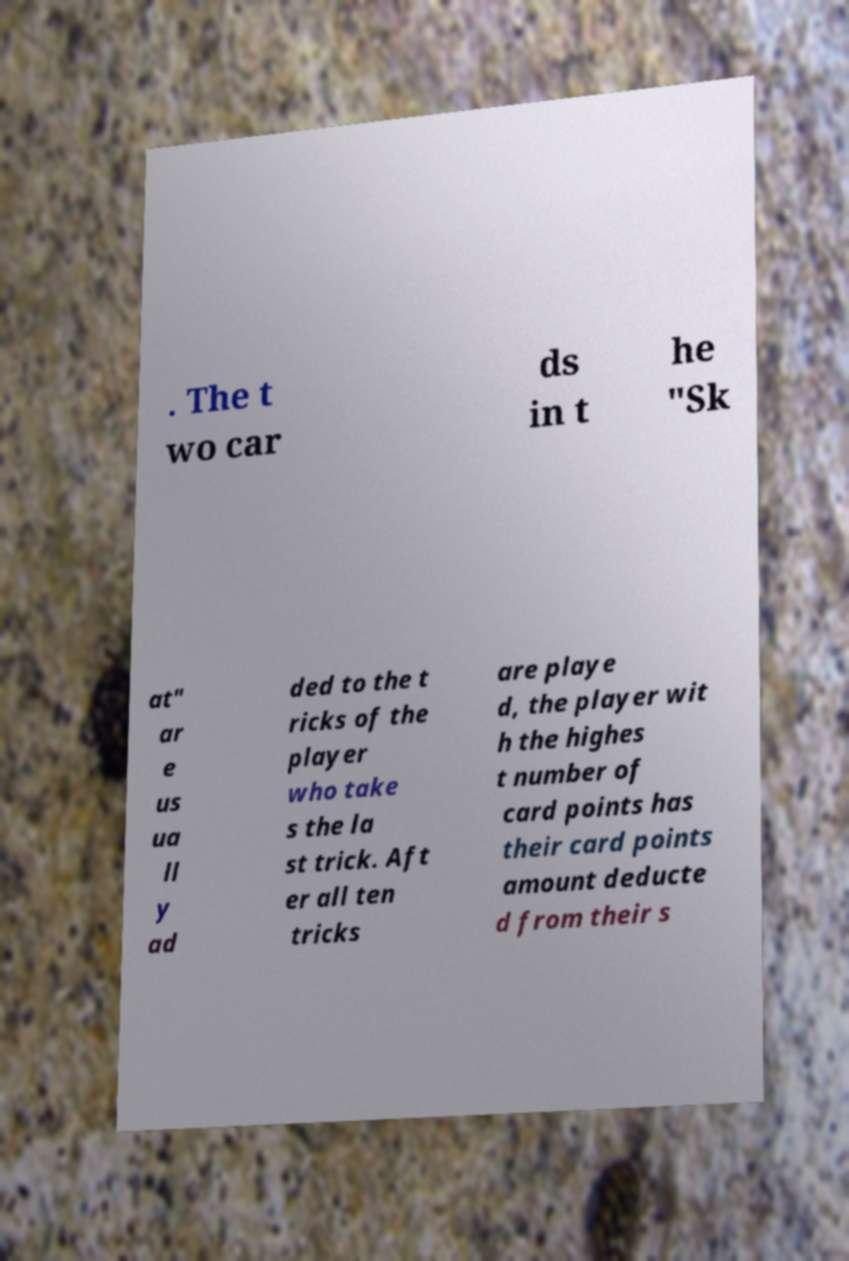Could you assist in decoding the text presented in this image and type it out clearly? . The t wo car ds in t he "Sk at" ar e us ua ll y ad ded to the t ricks of the player who take s the la st trick. Aft er all ten tricks are playe d, the player wit h the highes t number of card points has their card points amount deducte d from their s 